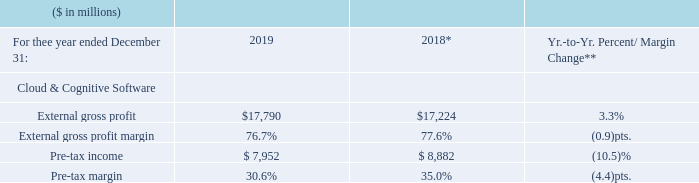* Recast to reflect segment changes.
** 2019 results were impacted by Red Hat purchase accounting and acquisition-related activity.
The Cloud & Cognitive Software gross profit margin decreased 0.9 points to 76.7 percent in 2019 compared to the prior year. The gross profit margin decline was driven by the purchase price accounting impacts from the Red Hat acquisition.
Pre-tax income of $7,952 million decreased 10.5 percent compared to the prior year with a pre-tax margin decline of 4.4 points to 30.6 percent which reflects the acquisition of Red Hat, ongoing investments in key strategic areas and lower income from IP partnership agreements.
In 2019, which activity impacted the result? 2019 results were impacted by red hat purchase accounting and acquisition-related activity. What caused the gross profit margin decline in 2019? The gross profit margin decline was driven by the purchase price accounting impacts from the red hat acquisition. What was the decrease in Pre-tax income in 2019? Pre-tax income of $7,952 million decreased 10.5 percent compared to the prior year with a pre-tax margin decline of 4.4 points to 30.6 percent which reflects the acquisition of red hat, ongoing investments in key strategic areas and lower income from ip partnership agreements. What was the average External gross profit in 2019 and 2018?
Answer scale should be: million. (17,790 + 17,224) / 2
Answer: 17507. What was the increase / (decrease) in the Pre-tax income from 2018 to 2019?
Answer scale should be: million. 7,952 - 8,882
Answer: -930. What was the average Pre tax margin in 2018 and 2019?
Answer scale should be: percent. (30.6% + 35.0%) / 2
Answer: 32.8. 